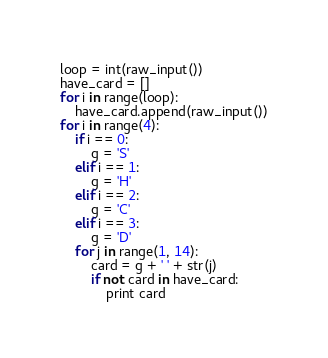<code> <loc_0><loc_0><loc_500><loc_500><_Python_>loop = int(raw_input())
have_card = []
for i in range(loop):
    have_card.append(raw_input())
for i in range(4):
    if i == 0:
        g = 'S'
    elif i == 1:
        g = 'H'
    elif i == 2:
        g = 'C'
    elif i == 3:
        g = 'D'
    for j in range(1, 14):
        card = g + ' ' + str(j)
        if not card in have_card:
            print card</code> 